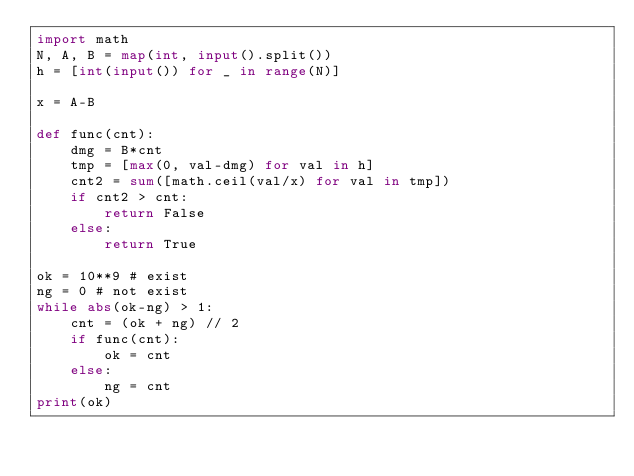<code> <loc_0><loc_0><loc_500><loc_500><_Python_>import math
N, A, B = map(int, input().split())
h = [int(input()) for _ in range(N)]

x = A-B

def func(cnt):
    dmg = B*cnt
    tmp = [max(0, val-dmg) for val in h]
    cnt2 = sum([math.ceil(val/x) for val in tmp])
    if cnt2 > cnt:
        return False
    else:
        return True

ok = 10**9 # exist
ng = 0 # not exist
while abs(ok-ng) > 1:
    cnt = (ok + ng) // 2
    if func(cnt):
        ok = cnt
    else:
        ng = cnt
print(ok)</code> 